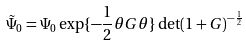Convert formula to latex. <formula><loc_0><loc_0><loc_500><loc_500>\tilde { \Psi } _ { 0 } = \Psi _ { 0 } \exp \{ - \frac { 1 } { 2 } \theta G \theta \} \det ( 1 + G ) ^ { - \frac { 1 } { 2 } }</formula> 